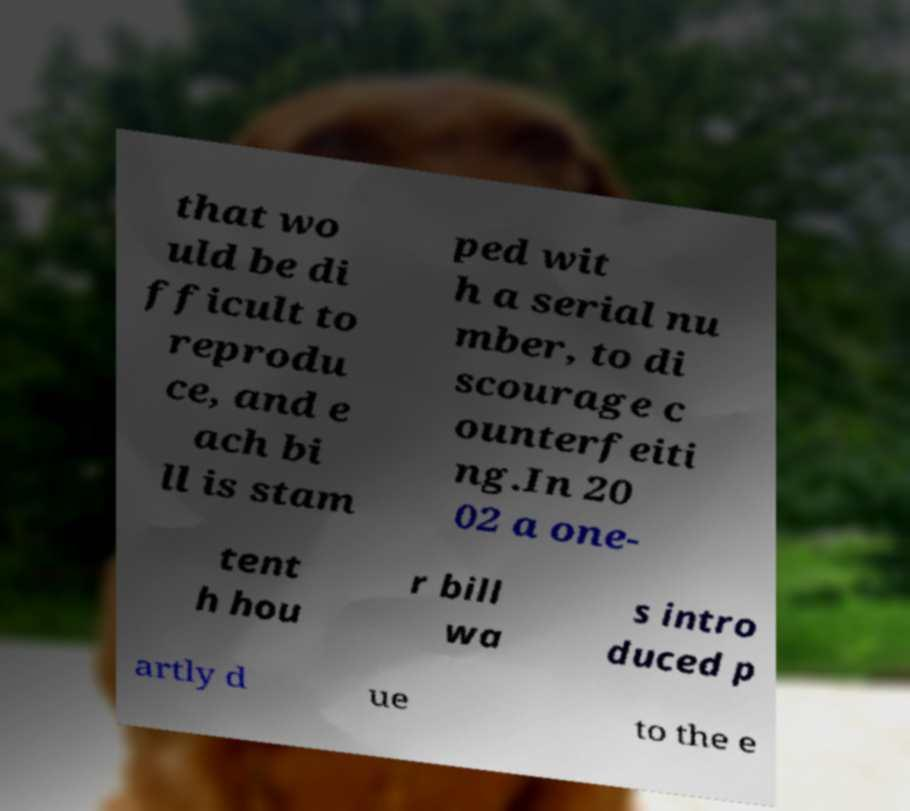Please read and relay the text visible in this image. What does it say? that wo uld be di fficult to reprodu ce, and e ach bi ll is stam ped wit h a serial nu mber, to di scourage c ounterfeiti ng.In 20 02 a one- tent h hou r bill wa s intro duced p artly d ue to the e 